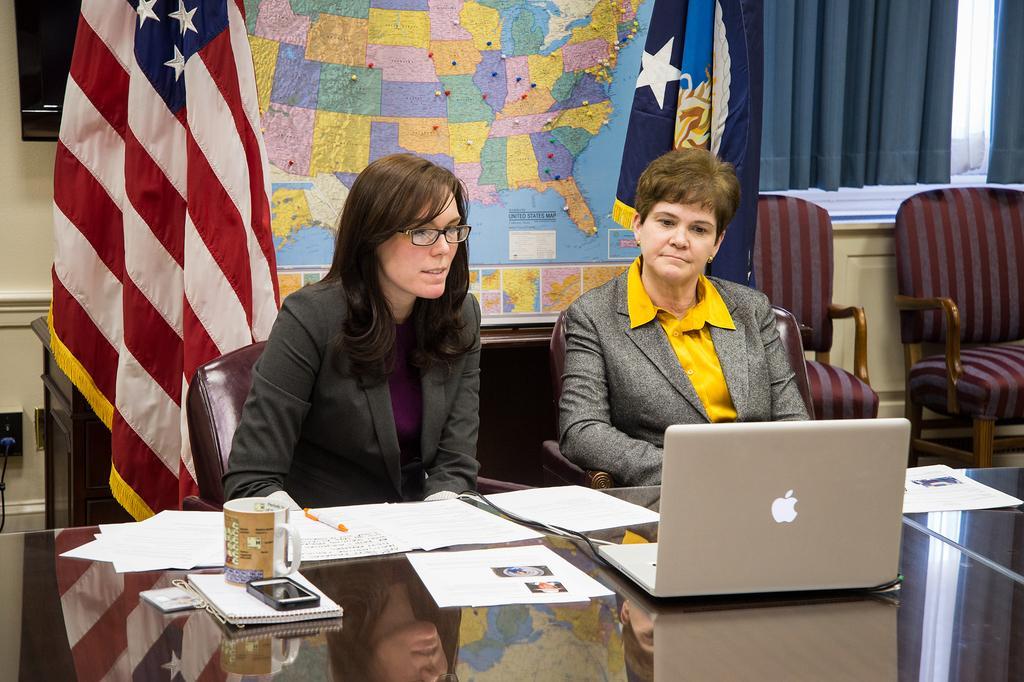Please provide a concise description of this image. In this image I can see a table and on the table I can see, few papers, a book, a cup, a mobile and a laptop. I can see two women sitting on chairs in front of the table. In the background I can see few flags, the wall, a screen, a map attached to the wall, the curtain, few chairs and the window. 